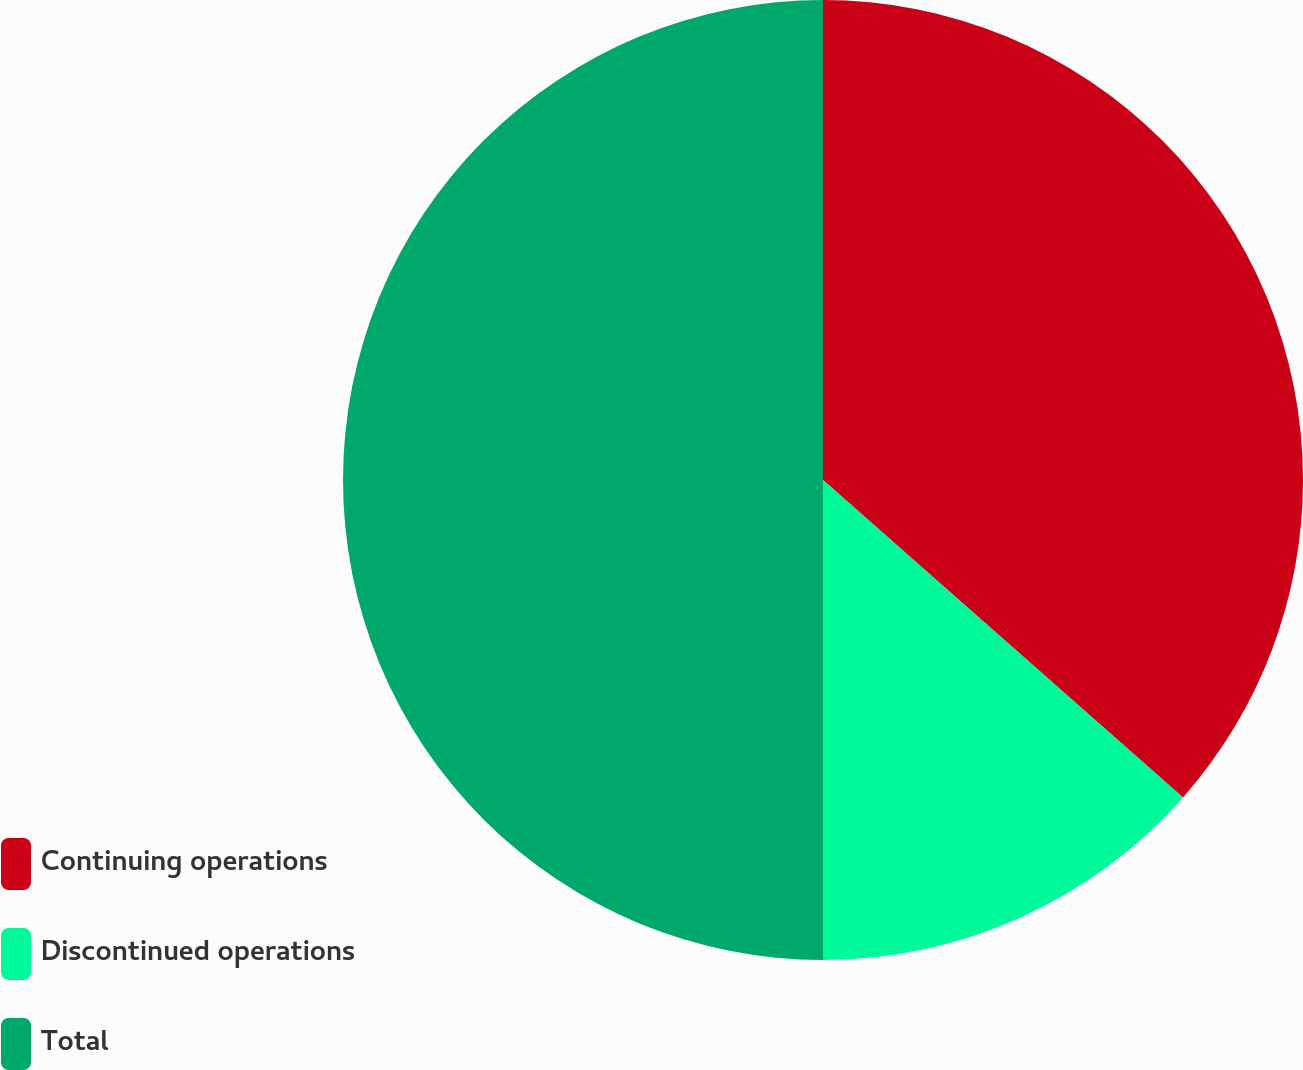<chart> <loc_0><loc_0><loc_500><loc_500><pie_chart><fcel>Continuing operations<fcel>Discontinued operations<fcel>Total<nl><fcel>36.5%<fcel>13.5%<fcel>50.0%<nl></chart> 